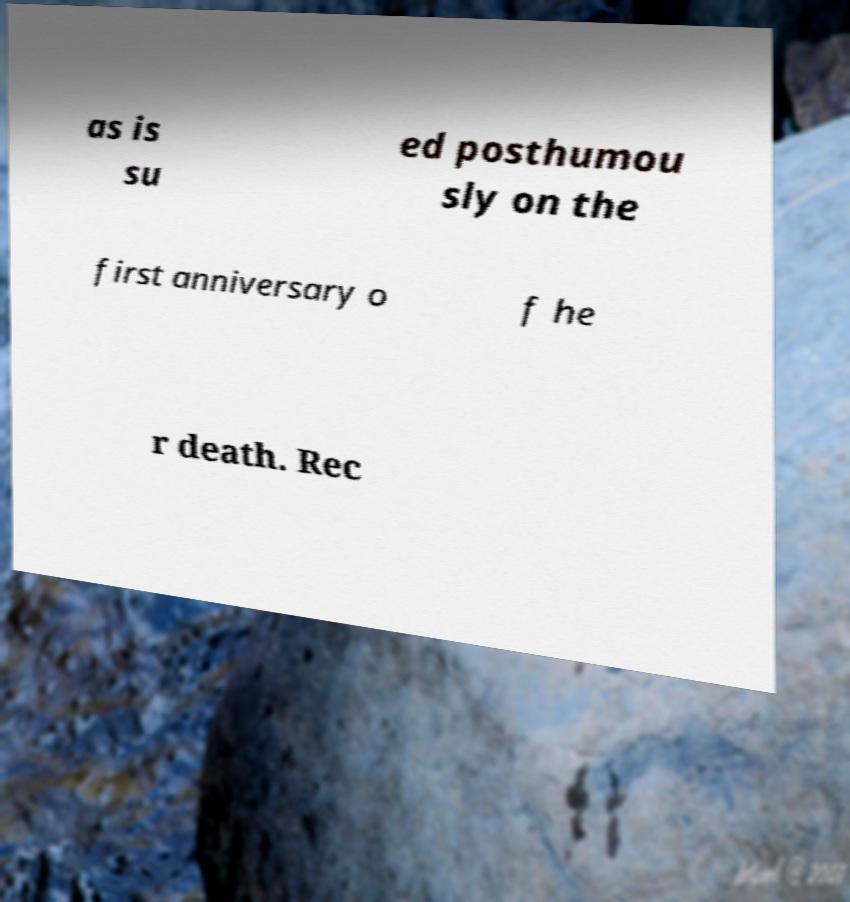There's text embedded in this image that I need extracted. Can you transcribe it verbatim? as is su ed posthumou sly on the first anniversary o f he r death. Rec 